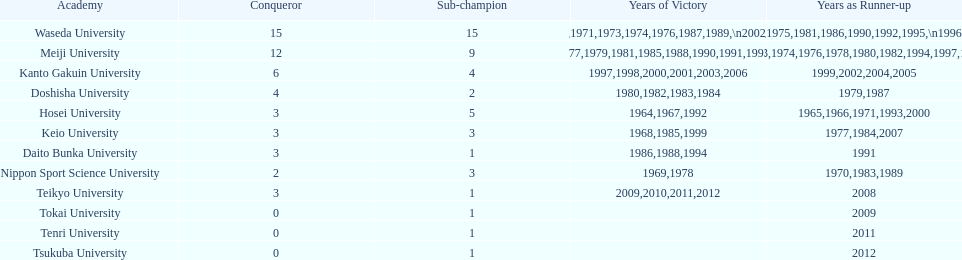Which university had the most years won? Waseda University. 